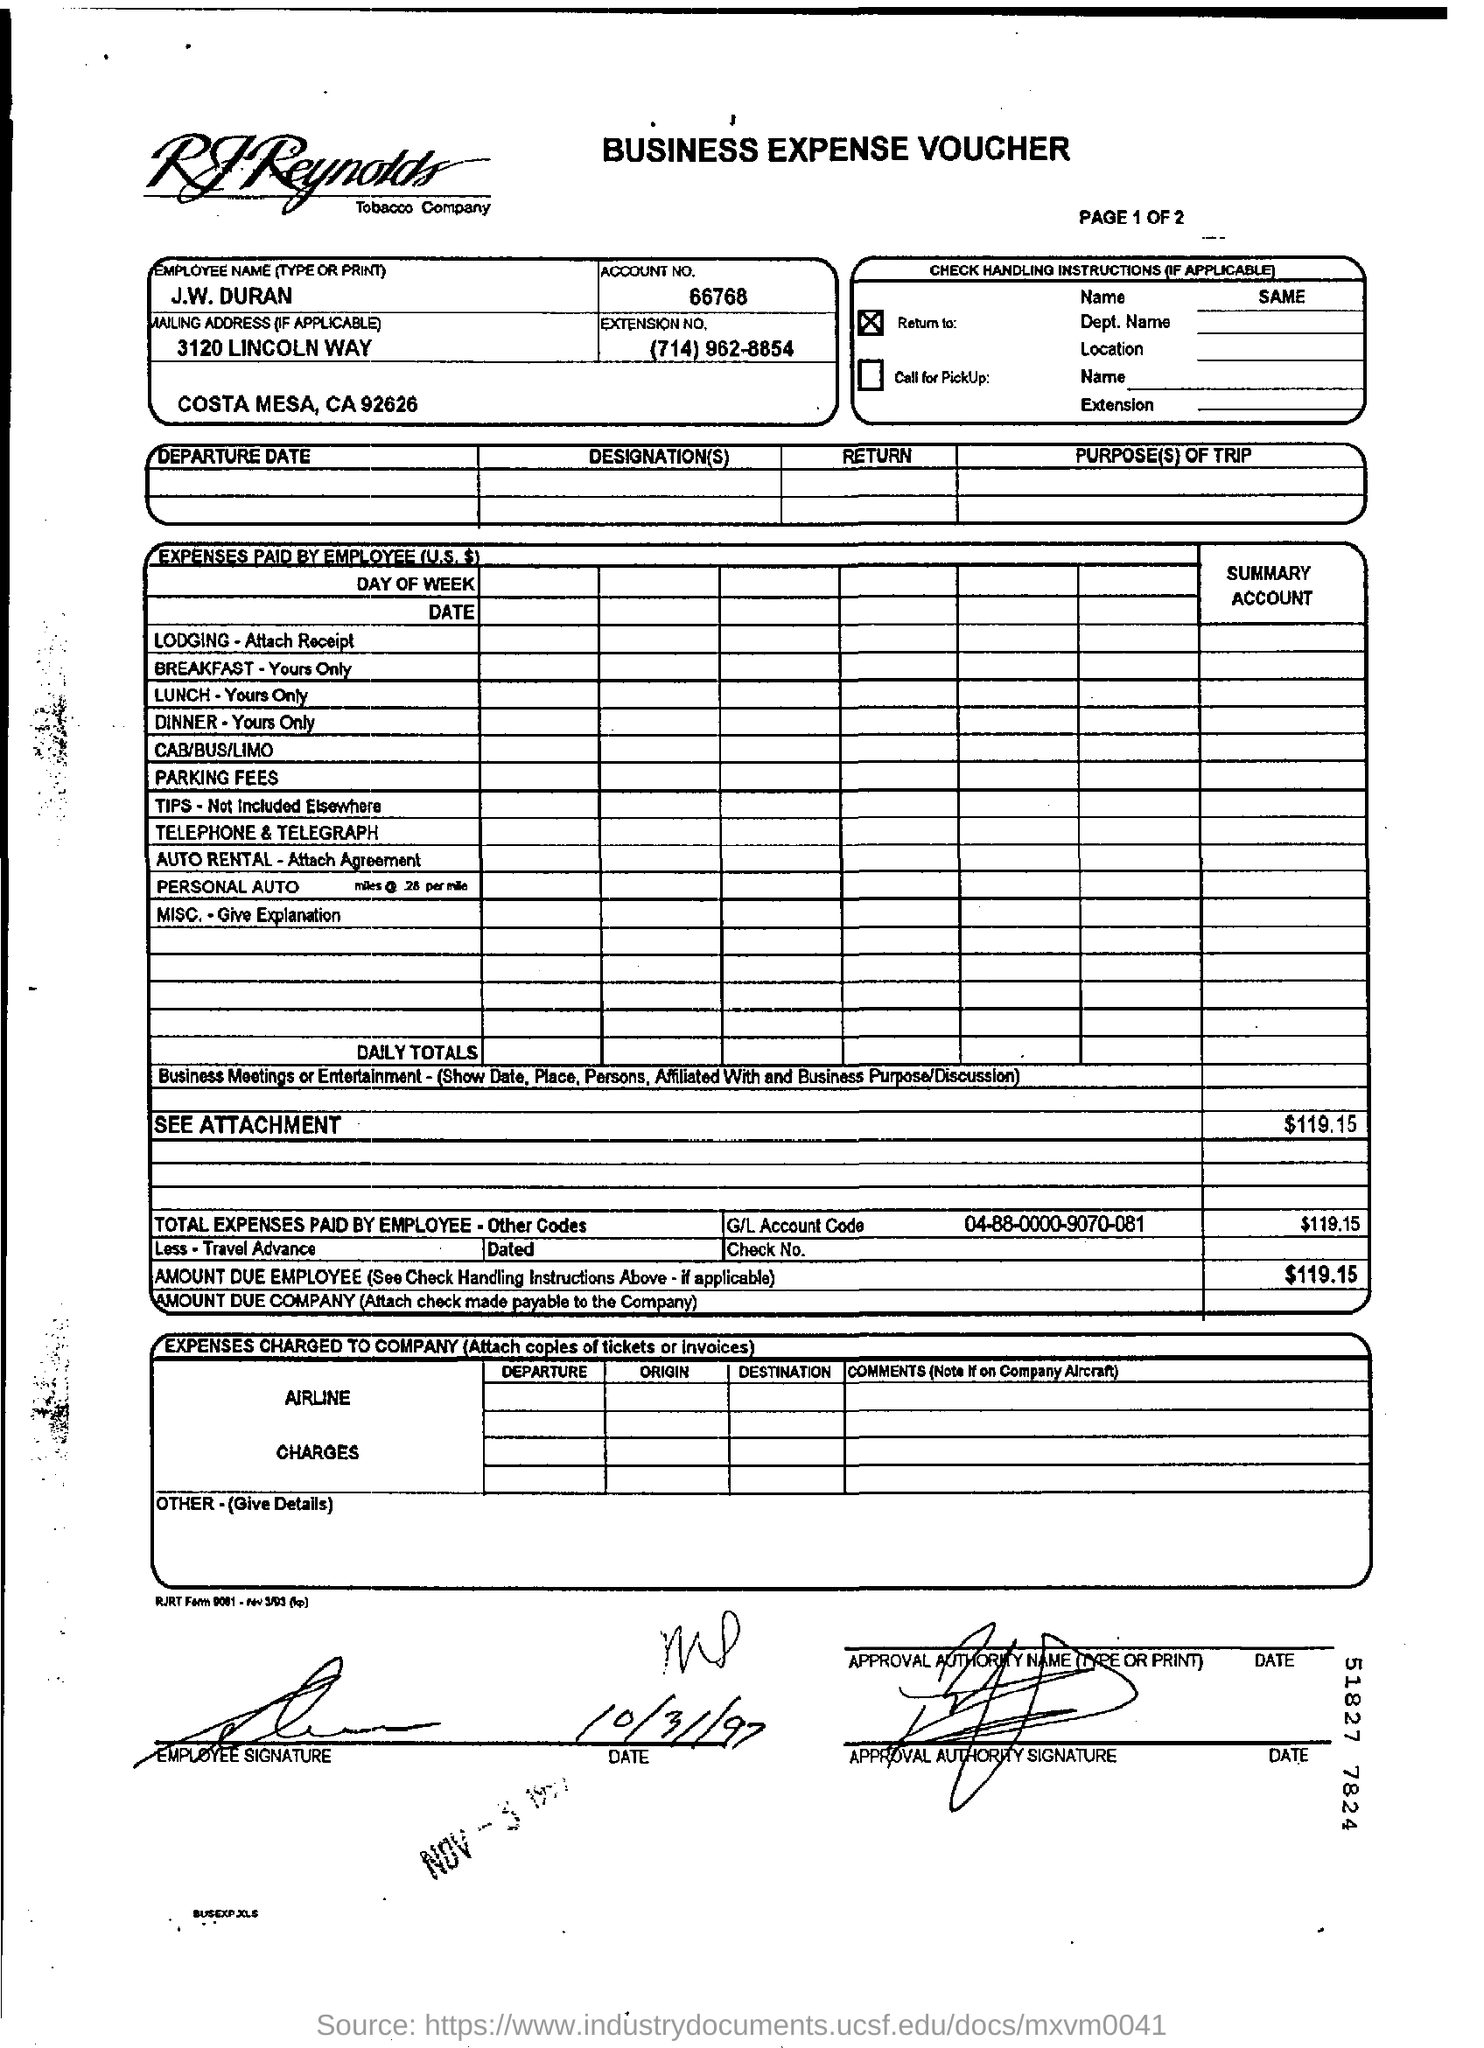Highlight a few significant elements in this photo. The account number is 66768. What is the General Ledger account code? It is 04-88-0000-9070-081. The employee's name is J.W. Duran. 